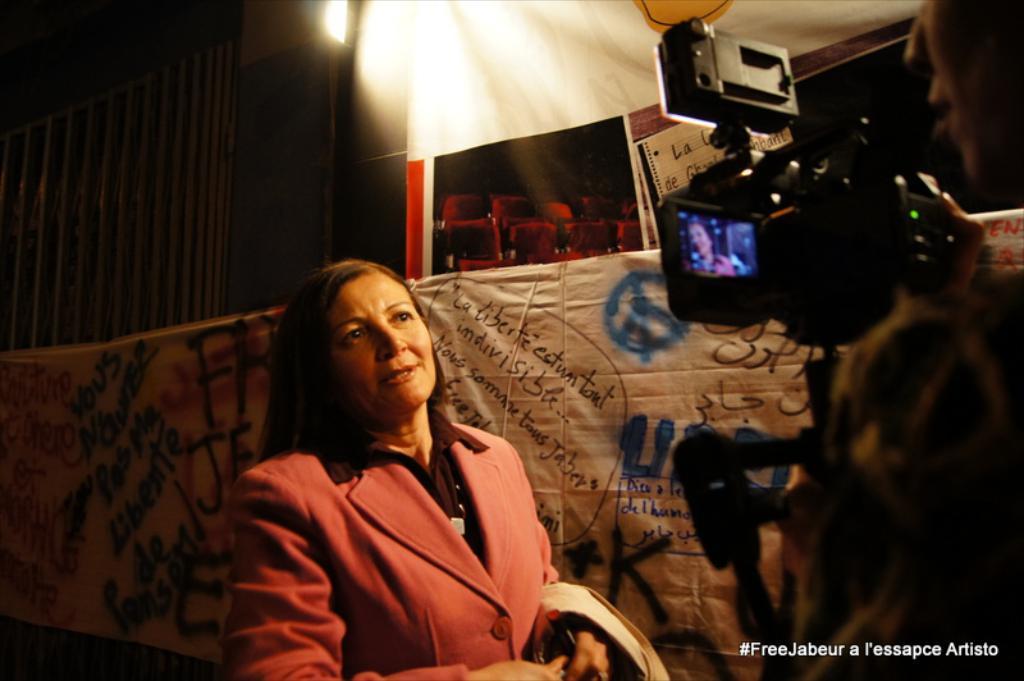Please provide a concise description of this image. In the picture I can see a woman wearing red color jacket is standing here, Here we can see a camera fixed to the tripod stand and a person is standing near that. In the background, I can see a banner upon which I can see some text is written, I can see some boards, the wall and light. Here I can see the watermark at the bottom right side of the image. 